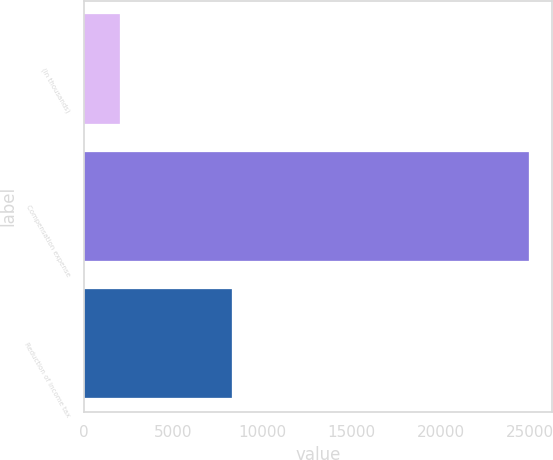Convert chart. <chart><loc_0><loc_0><loc_500><loc_500><bar_chart><fcel>(In thousands)<fcel>Compensation expense<fcel>Reduction of income tax<nl><fcel>2015<fcel>24974<fcel>8284<nl></chart> 